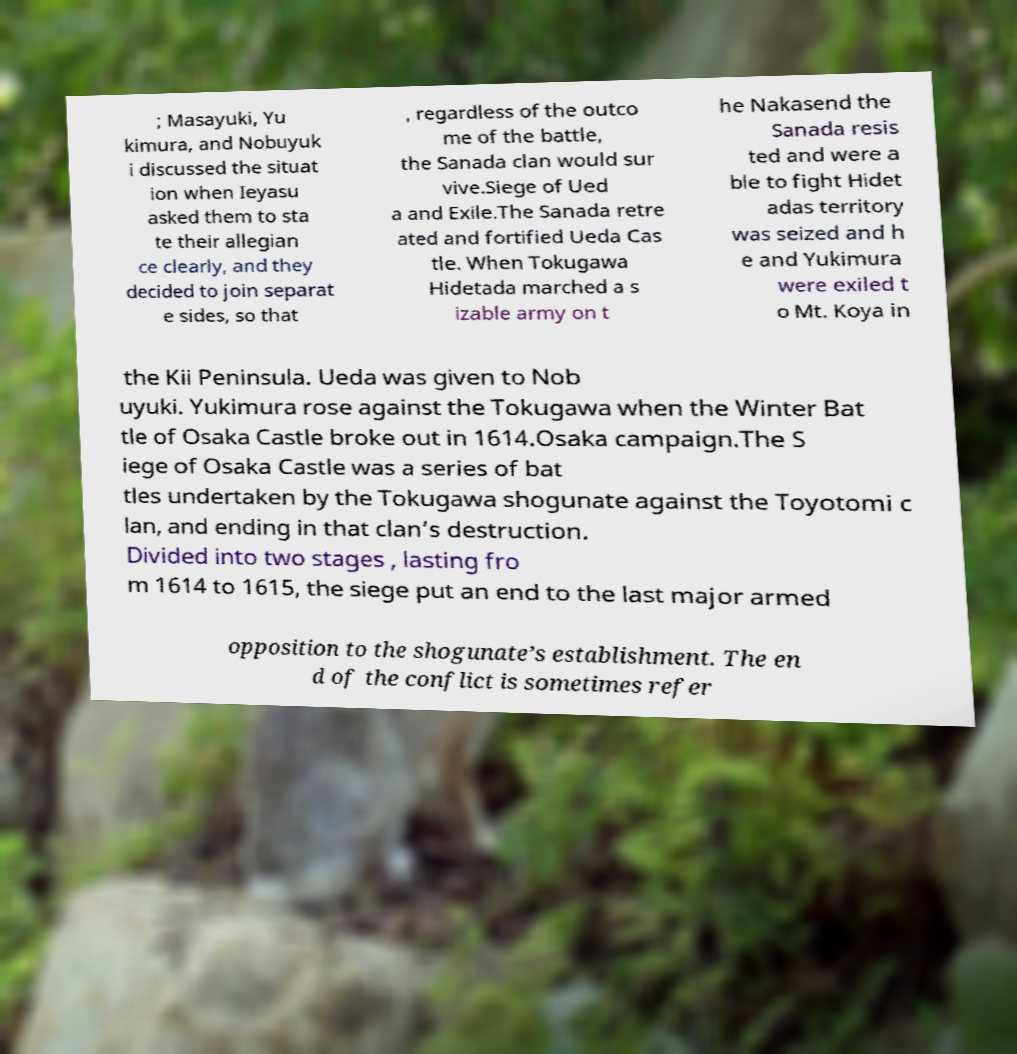Can you read and provide the text displayed in the image?This photo seems to have some interesting text. Can you extract and type it out for me? ; Masayuki, Yu kimura, and Nobuyuk i discussed the situat ion when Ieyasu asked them to sta te their allegian ce clearly, and they decided to join separat e sides, so that , regardless of the outco me of the battle, the Sanada clan would sur vive.Siege of Ued a and Exile.The Sanada retre ated and fortified Ueda Cas tle. When Tokugawa Hidetada marched a s izable army on t he Nakasend the Sanada resis ted and were a ble to fight Hidet adas territory was seized and h e and Yukimura were exiled t o Mt. Koya in the Kii Peninsula. Ueda was given to Nob uyuki. Yukimura rose against the Tokugawa when the Winter Bat tle of Osaka Castle broke out in 1614.Osaka campaign.The S iege of Osaka Castle was a series of bat tles undertaken by the Tokugawa shogunate against the Toyotomi c lan, and ending in that clan’s destruction. Divided into two stages , lasting fro m 1614 to 1615, the siege put an end to the last major armed opposition to the shogunate’s establishment. The en d of the conflict is sometimes refer 